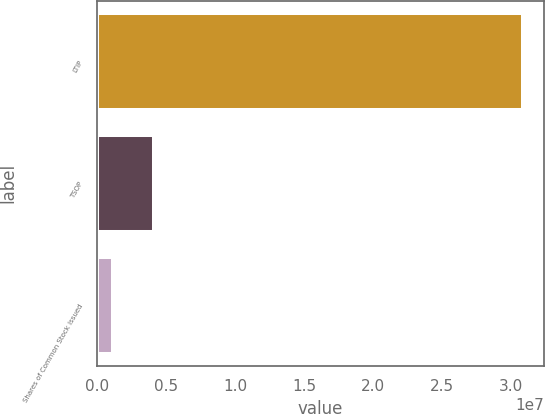<chart> <loc_0><loc_0><loc_500><loc_500><bar_chart><fcel>LTIP<fcel>TSOP<fcel>Shares of Common Stock issued<nl><fcel>3.08164e+07<fcel>4.11335e+06<fcel>1.14635e+06<nl></chart> 